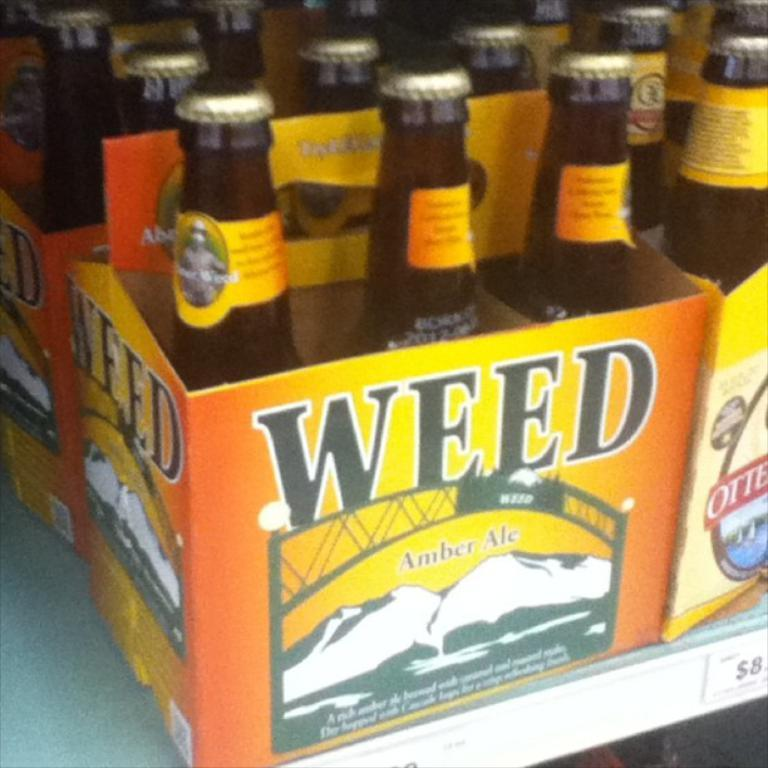<image>
Give a short and clear explanation of the subsequent image. A six pack of Weed amber ale beer in brown glass bottles. 